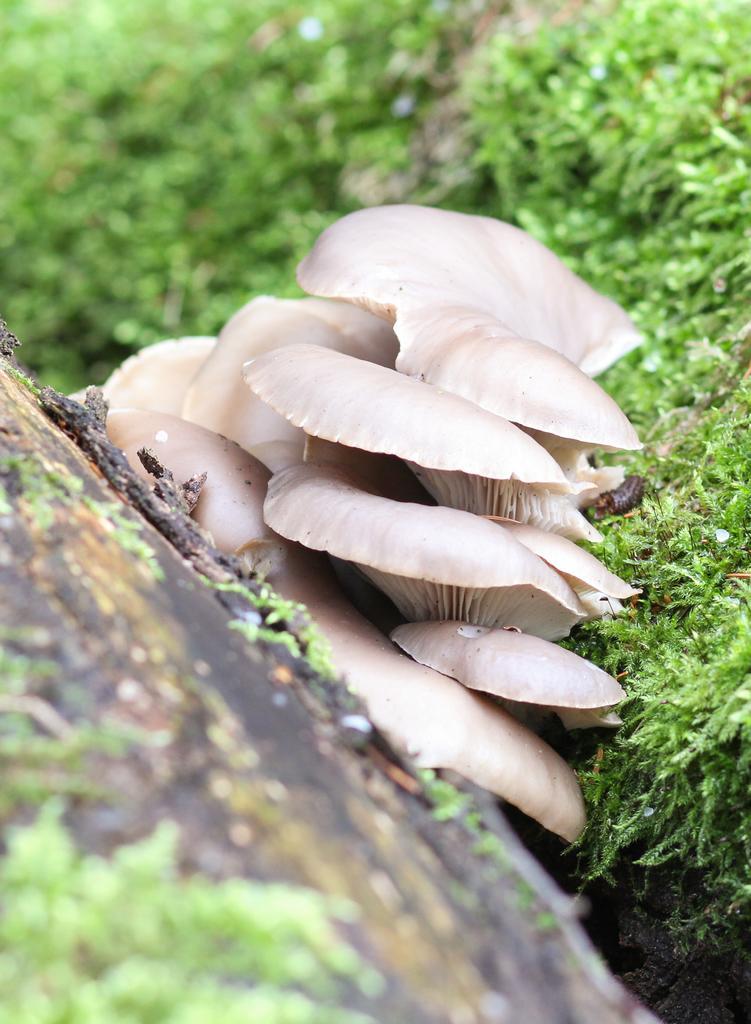Please provide a concise description of this image. In the image there is an oyster mushroom a beside the grass and the background of the mushroom is blur. 